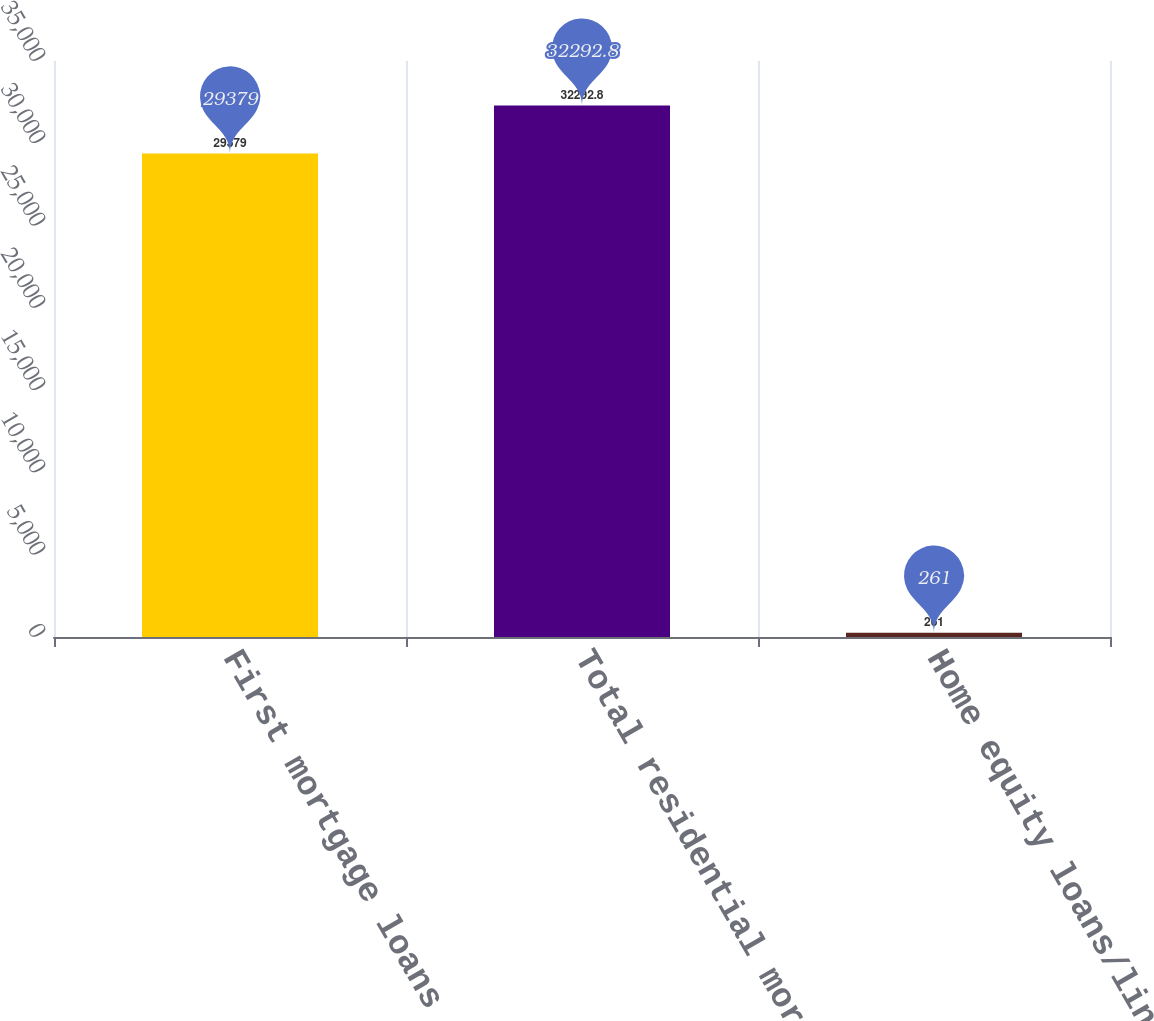Convert chart. <chart><loc_0><loc_0><loc_500><loc_500><bar_chart><fcel>First mortgage loans<fcel>Total residential mortgage<fcel>Home equity loans/lines<nl><fcel>29379<fcel>32292.8<fcel>261<nl></chart> 